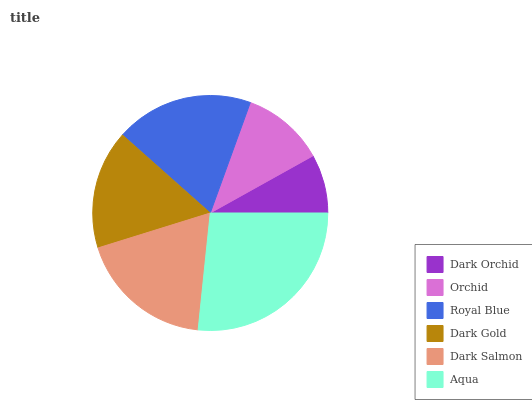Is Dark Orchid the minimum?
Answer yes or no. Yes. Is Aqua the maximum?
Answer yes or no. Yes. Is Orchid the minimum?
Answer yes or no. No. Is Orchid the maximum?
Answer yes or no. No. Is Orchid greater than Dark Orchid?
Answer yes or no. Yes. Is Dark Orchid less than Orchid?
Answer yes or no. Yes. Is Dark Orchid greater than Orchid?
Answer yes or no. No. Is Orchid less than Dark Orchid?
Answer yes or no. No. Is Dark Salmon the high median?
Answer yes or no. Yes. Is Dark Gold the low median?
Answer yes or no. Yes. Is Aqua the high median?
Answer yes or no. No. Is Dark Salmon the low median?
Answer yes or no. No. 